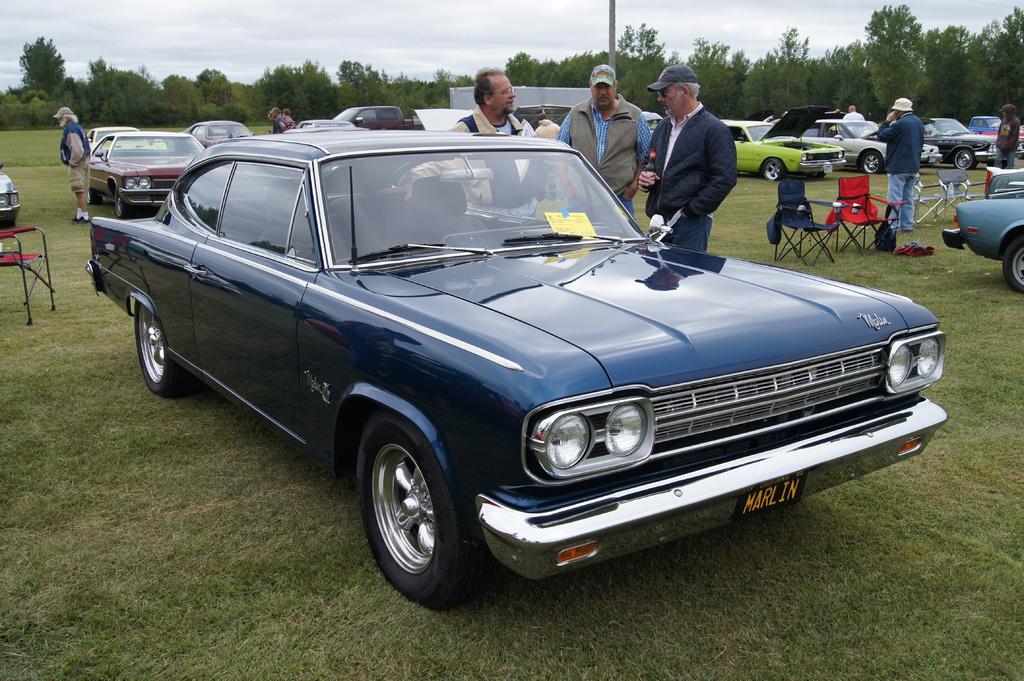What does the license plate say?
Your answer should be compact. Marlin. 